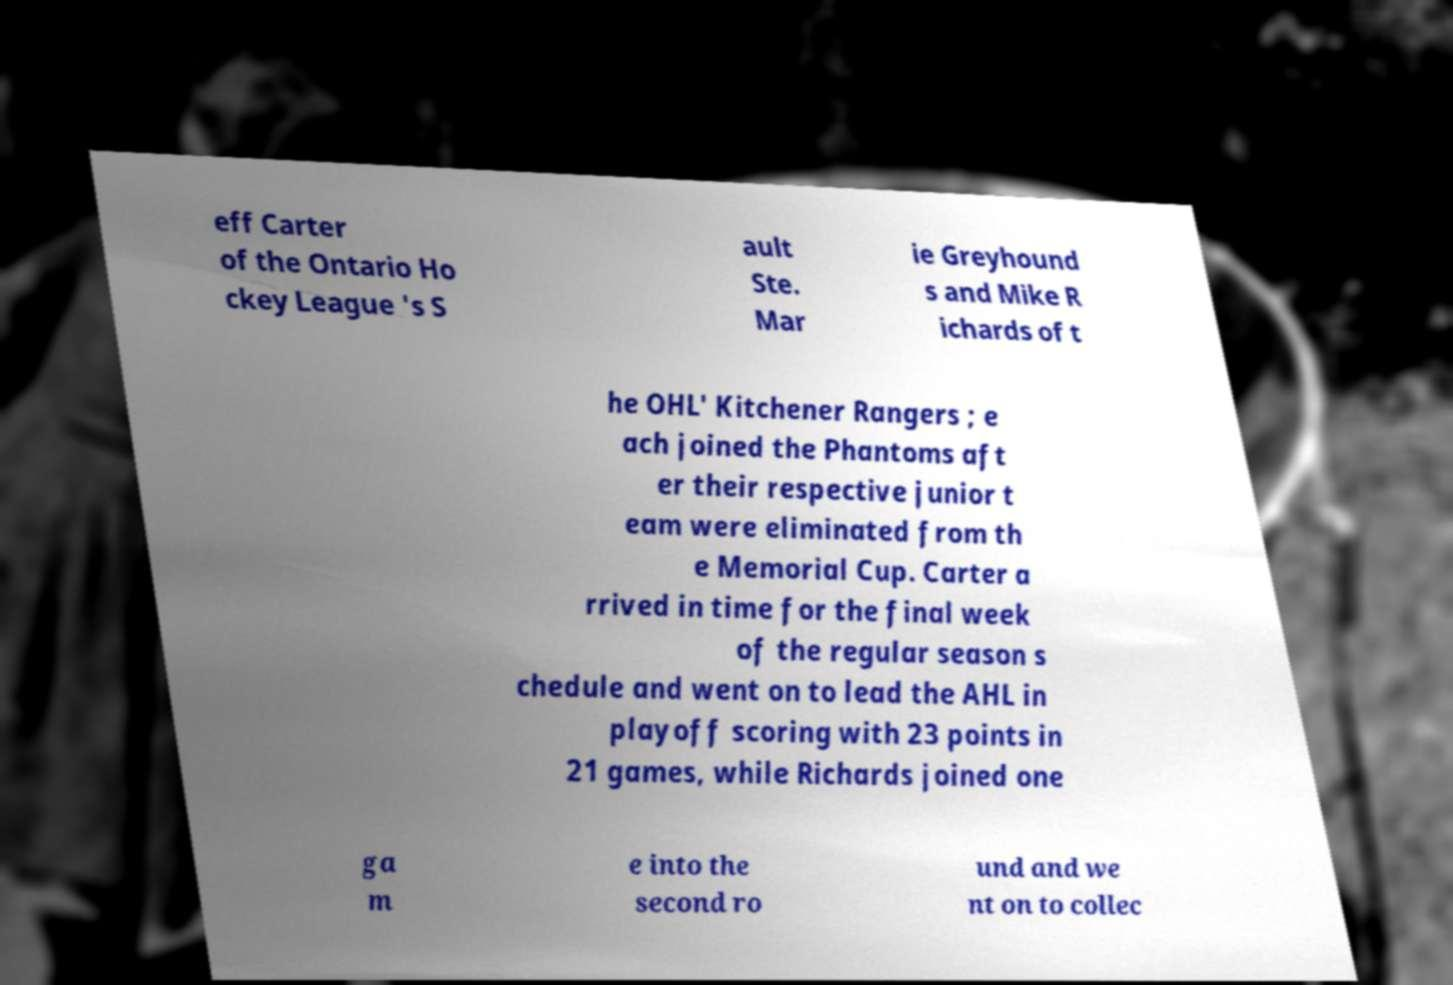Could you assist in decoding the text presented in this image and type it out clearly? eff Carter of the Ontario Ho ckey League 's S ault Ste. Mar ie Greyhound s and Mike R ichards of t he OHL' Kitchener Rangers ; e ach joined the Phantoms aft er their respective junior t eam were eliminated from th e Memorial Cup. Carter a rrived in time for the final week of the regular season s chedule and went on to lead the AHL in playoff scoring with 23 points in 21 games, while Richards joined one ga m e into the second ro und and we nt on to collec 